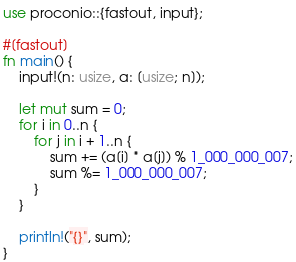<code> <loc_0><loc_0><loc_500><loc_500><_Rust_>use proconio::{fastout, input};

#[fastout]
fn main() {
    input!(n: usize, a: [usize; n]);

    let mut sum = 0;
    for i in 0..n {
        for j in i + 1..n {
            sum += (a[i] * a[j]) % 1_000_000_007;
            sum %= 1_000_000_007;
        }
    }

    println!("{}", sum);
}
</code> 